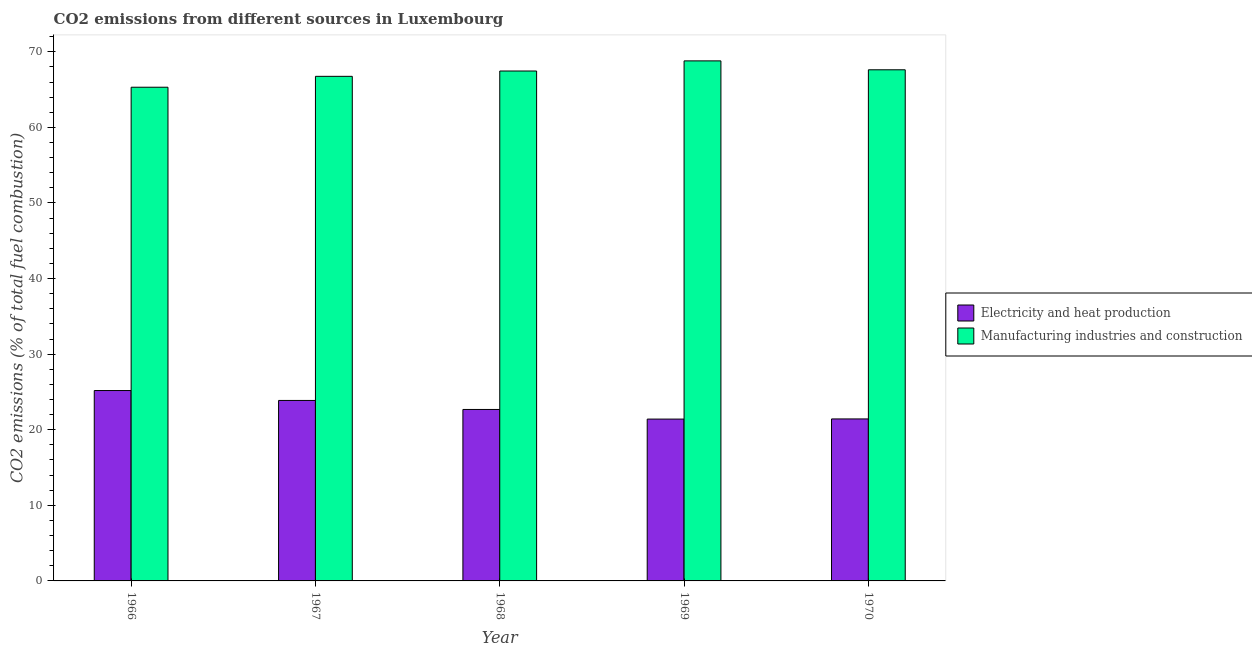How many different coloured bars are there?
Offer a terse response. 2. Are the number of bars per tick equal to the number of legend labels?
Ensure brevity in your answer.  Yes. How many bars are there on the 3rd tick from the right?
Keep it short and to the point. 2. What is the label of the 3rd group of bars from the left?
Offer a very short reply. 1968. In how many cases, is the number of bars for a given year not equal to the number of legend labels?
Your answer should be very brief. 0. What is the co2 emissions due to manufacturing industries in 1968?
Provide a short and direct response. 67.45. Across all years, what is the maximum co2 emissions due to electricity and heat production?
Your answer should be compact. 25.19. Across all years, what is the minimum co2 emissions due to electricity and heat production?
Offer a terse response. 21.41. In which year was the co2 emissions due to manufacturing industries maximum?
Your answer should be very brief. 1969. In which year was the co2 emissions due to electricity and heat production minimum?
Offer a terse response. 1969. What is the total co2 emissions due to manufacturing industries in the graph?
Keep it short and to the point. 335.92. What is the difference between the co2 emissions due to electricity and heat production in 1968 and that in 1970?
Make the answer very short. 1.25. What is the difference between the co2 emissions due to electricity and heat production in 1969 and the co2 emissions due to manufacturing industries in 1968?
Your answer should be very brief. -1.27. What is the average co2 emissions due to electricity and heat production per year?
Make the answer very short. 22.92. In the year 1968, what is the difference between the co2 emissions due to electricity and heat production and co2 emissions due to manufacturing industries?
Ensure brevity in your answer.  0. In how many years, is the co2 emissions due to manufacturing industries greater than 36 %?
Give a very brief answer. 5. What is the ratio of the co2 emissions due to electricity and heat production in 1966 to that in 1967?
Offer a terse response. 1.05. Is the co2 emissions due to electricity and heat production in 1968 less than that in 1969?
Offer a terse response. No. What is the difference between the highest and the second highest co2 emissions due to electricity and heat production?
Ensure brevity in your answer.  1.31. What is the difference between the highest and the lowest co2 emissions due to manufacturing industries?
Make the answer very short. 3.49. In how many years, is the co2 emissions due to electricity and heat production greater than the average co2 emissions due to electricity and heat production taken over all years?
Your response must be concise. 2. Is the sum of the co2 emissions due to electricity and heat production in 1967 and 1970 greater than the maximum co2 emissions due to manufacturing industries across all years?
Provide a short and direct response. Yes. What does the 2nd bar from the left in 1970 represents?
Provide a short and direct response. Manufacturing industries and construction. What does the 2nd bar from the right in 1970 represents?
Give a very brief answer. Electricity and heat production. How many years are there in the graph?
Make the answer very short. 5. What is the difference between two consecutive major ticks on the Y-axis?
Your answer should be compact. 10. Are the values on the major ticks of Y-axis written in scientific E-notation?
Make the answer very short. No. How many legend labels are there?
Offer a very short reply. 2. What is the title of the graph?
Ensure brevity in your answer.  CO2 emissions from different sources in Luxembourg. Does "Net savings(excluding particulate emission damage)" appear as one of the legend labels in the graph?
Provide a short and direct response. No. What is the label or title of the X-axis?
Give a very brief answer. Year. What is the label or title of the Y-axis?
Make the answer very short. CO2 emissions (% of total fuel combustion). What is the CO2 emissions (% of total fuel combustion) of Electricity and heat production in 1966?
Keep it short and to the point. 25.19. What is the CO2 emissions (% of total fuel combustion) of Manufacturing industries and construction in 1966?
Provide a short and direct response. 65.31. What is the CO2 emissions (% of total fuel combustion) in Electricity and heat production in 1967?
Make the answer very short. 23.87. What is the CO2 emissions (% of total fuel combustion) of Manufacturing industries and construction in 1967?
Provide a short and direct response. 66.75. What is the CO2 emissions (% of total fuel combustion) of Electricity and heat production in 1968?
Give a very brief answer. 22.68. What is the CO2 emissions (% of total fuel combustion) of Manufacturing industries and construction in 1968?
Provide a succinct answer. 67.45. What is the CO2 emissions (% of total fuel combustion) in Electricity and heat production in 1969?
Offer a terse response. 21.41. What is the CO2 emissions (% of total fuel combustion) in Manufacturing industries and construction in 1969?
Ensure brevity in your answer.  68.79. What is the CO2 emissions (% of total fuel combustion) of Electricity and heat production in 1970?
Provide a short and direct response. 21.43. What is the CO2 emissions (% of total fuel combustion) of Manufacturing industries and construction in 1970?
Offer a very short reply. 67.62. Across all years, what is the maximum CO2 emissions (% of total fuel combustion) in Electricity and heat production?
Give a very brief answer. 25.19. Across all years, what is the maximum CO2 emissions (% of total fuel combustion) in Manufacturing industries and construction?
Make the answer very short. 68.79. Across all years, what is the minimum CO2 emissions (% of total fuel combustion) in Electricity and heat production?
Offer a terse response. 21.41. Across all years, what is the minimum CO2 emissions (% of total fuel combustion) in Manufacturing industries and construction?
Your response must be concise. 65.31. What is the total CO2 emissions (% of total fuel combustion) of Electricity and heat production in the graph?
Offer a terse response. 114.58. What is the total CO2 emissions (% of total fuel combustion) in Manufacturing industries and construction in the graph?
Offer a very short reply. 335.92. What is the difference between the CO2 emissions (% of total fuel combustion) in Electricity and heat production in 1966 and that in 1967?
Make the answer very short. 1.31. What is the difference between the CO2 emissions (% of total fuel combustion) of Manufacturing industries and construction in 1966 and that in 1967?
Offer a very short reply. -1.44. What is the difference between the CO2 emissions (% of total fuel combustion) in Electricity and heat production in 1966 and that in 1968?
Keep it short and to the point. 2.5. What is the difference between the CO2 emissions (% of total fuel combustion) of Manufacturing industries and construction in 1966 and that in 1968?
Provide a succinct answer. -2.15. What is the difference between the CO2 emissions (% of total fuel combustion) in Electricity and heat production in 1966 and that in 1969?
Your response must be concise. 3.78. What is the difference between the CO2 emissions (% of total fuel combustion) of Manufacturing industries and construction in 1966 and that in 1969?
Provide a short and direct response. -3.49. What is the difference between the CO2 emissions (% of total fuel combustion) of Electricity and heat production in 1966 and that in 1970?
Ensure brevity in your answer.  3.76. What is the difference between the CO2 emissions (% of total fuel combustion) in Manufacturing industries and construction in 1966 and that in 1970?
Offer a terse response. -2.31. What is the difference between the CO2 emissions (% of total fuel combustion) of Electricity and heat production in 1967 and that in 1968?
Give a very brief answer. 1.19. What is the difference between the CO2 emissions (% of total fuel combustion) of Manufacturing industries and construction in 1967 and that in 1968?
Offer a very short reply. -0.71. What is the difference between the CO2 emissions (% of total fuel combustion) in Electricity and heat production in 1967 and that in 1969?
Ensure brevity in your answer.  2.47. What is the difference between the CO2 emissions (% of total fuel combustion) of Manufacturing industries and construction in 1967 and that in 1969?
Your answer should be very brief. -2.05. What is the difference between the CO2 emissions (% of total fuel combustion) of Electricity and heat production in 1967 and that in 1970?
Your answer should be compact. 2.45. What is the difference between the CO2 emissions (% of total fuel combustion) in Manufacturing industries and construction in 1967 and that in 1970?
Provide a succinct answer. -0.87. What is the difference between the CO2 emissions (% of total fuel combustion) of Electricity and heat production in 1968 and that in 1969?
Provide a short and direct response. 1.27. What is the difference between the CO2 emissions (% of total fuel combustion) in Manufacturing industries and construction in 1968 and that in 1969?
Your response must be concise. -1.34. What is the difference between the CO2 emissions (% of total fuel combustion) of Electricity and heat production in 1968 and that in 1970?
Your answer should be very brief. 1.25. What is the difference between the CO2 emissions (% of total fuel combustion) of Manufacturing industries and construction in 1968 and that in 1970?
Offer a very short reply. -0.16. What is the difference between the CO2 emissions (% of total fuel combustion) in Electricity and heat production in 1969 and that in 1970?
Provide a succinct answer. -0.02. What is the difference between the CO2 emissions (% of total fuel combustion) in Manufacturing industries and construction in 1969 and that in 1970?
Keep it short and to the point. 1.18. What is the difference between the CO2 emissions (% of total fuel combustion) in Electricity and heat production in 1966 and the CO2 emissions (% of total fuel combustion) in Manufacturing industries and construction in 1967?
Your response must be concise. -41.56. What is the difference between the CO2 emissions (% of total fuel combustion) in Electricity and heat production in 1966 and the CO2 emissions (% of total fuel combustion) in Manufacturing industries and construction in 1968?
Your response must be concise. -42.27. What is the difference between the CO2 emissions (% of total fuel combustion) of Electricity and heat production in 1966 and the CO2 emissions (% of total fuel combustion) of Manufacturing industries and construction in 1969?
Provide a short and direct response. -43.61. What is the difference between the CO2 emissions (% of total fuel combustion) of Electricity and heat production in 1966 and the CO2 emissions (% of total fuel combustion) of Manufacturing industries and construction in 1970?
Provide a short and direct response. -42.43. What is the difference between the CO2 emissions (% of total fuel combustion) in Electricity and heat production in 1967 and the CO2 emissions (% of total fuel combustion) in Manufacturing industries and construction in 1968?
Provide a succinct answer. -43.58. What is the difference between the CO2 emissions (% of total fuel combustion) of Electricity and heat production in 1967 and the CO2 emissions (% of total fuel combustion) of Manufacturing industries and construction in 1969?
Your answer should be very brief. -44.92. What is the difference between the CO2 emissions (% of total fuel combustion) in Electricity and heat production in 1967 and the CO2 emissions (% of total fuel combustion) in Manufacturing industries and construction in 1970?
Offer a terse response. -43.74. What is the difference between the CO2 emissions (% of total fuel combustion) in Electricity and heat production in 1968 and the CO2 emissions (% of total fuel combustion) in Manufacturing industries and construction in 1969?
Give a very brief answer. -46.11. What is the difference between the CO2 emissions (% of total fuel combustion) in Electricity and heat production in 1968 and the CO2 emissions (% of total fuel combustion) in Manufacturing industries and construction in 1970?
Ensure brevity in your answer.  -44.93. What is the difference between the CO2 emissions (% of total fuel combustion) in Electricity and heat production in 1969 and the CO2 emissions (% of total fuel combustion) in Manufacturing industries and construction in 1970?
Make the answer very short. -46.21. What is the average CO2 emissions (% of total fuel combustion) of Electricity and heat production per year?
Make the answer very short. 22.92. What is the average CO2 emissions (% of total fuel combustion) in Manufacturing industries and construction per year?
Offer a very short reply. 67.18. In the year 1966, what is the difference between the CO2 emissions (% of total fuel combustion) of Electricity and heat production and CO2 emissions (% of total fuel combustion) of Manufacturing industries and construction?
Your answer should be very brief. -40.12. In the year 1967, what is the difference between the CO2 emissions (% of total fuel combustion) in Electricity and heat production and CO2 emissions (% of total fuel combustion) in Manufacturing industries and construction?
Your answer should be very brief. -42.87. In the year 1968, what is the difference between the CO2 emissions (% of total fuel combustion) in Electricity and heat production and CO2 emissions (% of total fuel combustion) in Manufacturing industries and construction?
Provide a succinct answer. -44.77. In the year 1969, what is the difference between the CO2 emissions (% of total fuel combustion) of Electricity and heat production and CO2 emissions (% of total fuel combustion) of Manufacturing industries and construction?
Your answer should be compact. -47.39. In the year 1970, what is the difference between the CO2 emissions (% of total fuel combustion) in Electricity and heat production and CO2 emissions (% of total fuel combustion) in Manufacturing industries and construction?
Give a very brief answer. -46.19. What is the ratio of the CO2 emissions (% of total fuel combustion) of Electricity and heat production in 1966 to that in 1967?
Offer a very short reply. 1.05. What is the ratio of the CO2 emissions (% of total fuel combustion) in Manufacturing industries and construction in 1966 to that in 1967?
Give a very brief answer. 0.98. What is the ratio of the CO2 emissions (% of total fuel combustion) of Electricity and heat production in 1966 to that in 1968?
Provide a succinct answer. 1.11. What is the ratio of the CO2 emissions (% of total fuel combustion) in Manufacturing industries and construction in 1966 to that in 1968?
Provide a succinct answer. 0.97. What is the ratio of the CO2 emissions (% of total fuel combustion) of Electricity and heat production in 1966 to that in 1969?
Offer a very short reply. 1.18. What is the ratio of the CO2 emissions (% of total fuel combustion) in Manufacturing industries and construction in 1966 to that in 1969?
Offer a very short reply. 0.95. What is the ratio of the CO2 emissions (% of total fuel combustion) in Electricity and heat production in 1966 to that in 1970?
Provide a succinct answer. 1.18. What is the ratio of the CO2 emissions (% of total fuel combustion) of Manufacturing industries and construction in 1966 to that in 1970?
Your answer should be compact. 0.97. What is the ratio of the CO2 emissions (% of total fuel combustion) in Electricity and heat production in 1967 to that in 1968?
Offer a terse response. 1.05. What is the ratio of the CO2 emissions (% of total fuel combustion) in Manufacturing industries and construction in 1967 to that in 1968?
Offer a terse response. 0.99. What is the ratio of the CO2 emissions (% of total fuel combustion) in Electricity and heat production in 1967 to that in 1969?
Offer a terse response. 1.12. What is the ratio of the CO2 emissions (% of total fuel combustion) in Manufacturing industries and construction in 1967 to that in 1969?
Provide a succinct answer. 0.97. What is the ratio of the CO2 emissions (% of total fuel combustion) of Electricity and heat production in 1967 to that in 1970?
Ensure brevity in your answer.  1.11. What is the ratio of the CO2 emissions (% of total fuel combustion) of Manufacturing industries and construction in 1967 to that in 1970?
Offer a very short reply. 0.99. What is the ratio of the CO2 emissions (% of total fuel combustion) of Electricity and heat production in 1968 to that in 1969?
Provide a succinct answer. 1.06. What is the ratio of the CO2 emissions (% of total fuel combustion) in Manufacturing industries and construction in 1968 to that in 1969?
Your answer should be compact. 0.98. What is the ratio of the CO2 emissions (% of total fuel combustion) of Electricity and heat production in 1968 to that in 1970?
Keep it short and to the point. 1.06. What is the ratio of the CO2 emissions (% of total fuel combustion) in Manufacturing industries and construction in 1969 to that in 1970?
Offer a terse response. 1.02. What is the difference between the highest and the second highest CO2 emissions (% of total fuel combustion) in Electricity and heat production?
Give a very brief answer. 1.31. What is the difference between the highest and the second highest CO2 emissions (% of total fuel combustion) in Manufacturing industries and construction?
Make the answer very short. 1.18. What is the difference between the highest and the lowest CO2 emissions (% of total fuel combustion) in Electricity and heat production?
Offer a very short reply. 3.78. What is the difference between the highest and the lowest CO2 emissions (% of total fuel combustion) of Manufacturing industries and construction?
Make the answer very short. 3.49. 